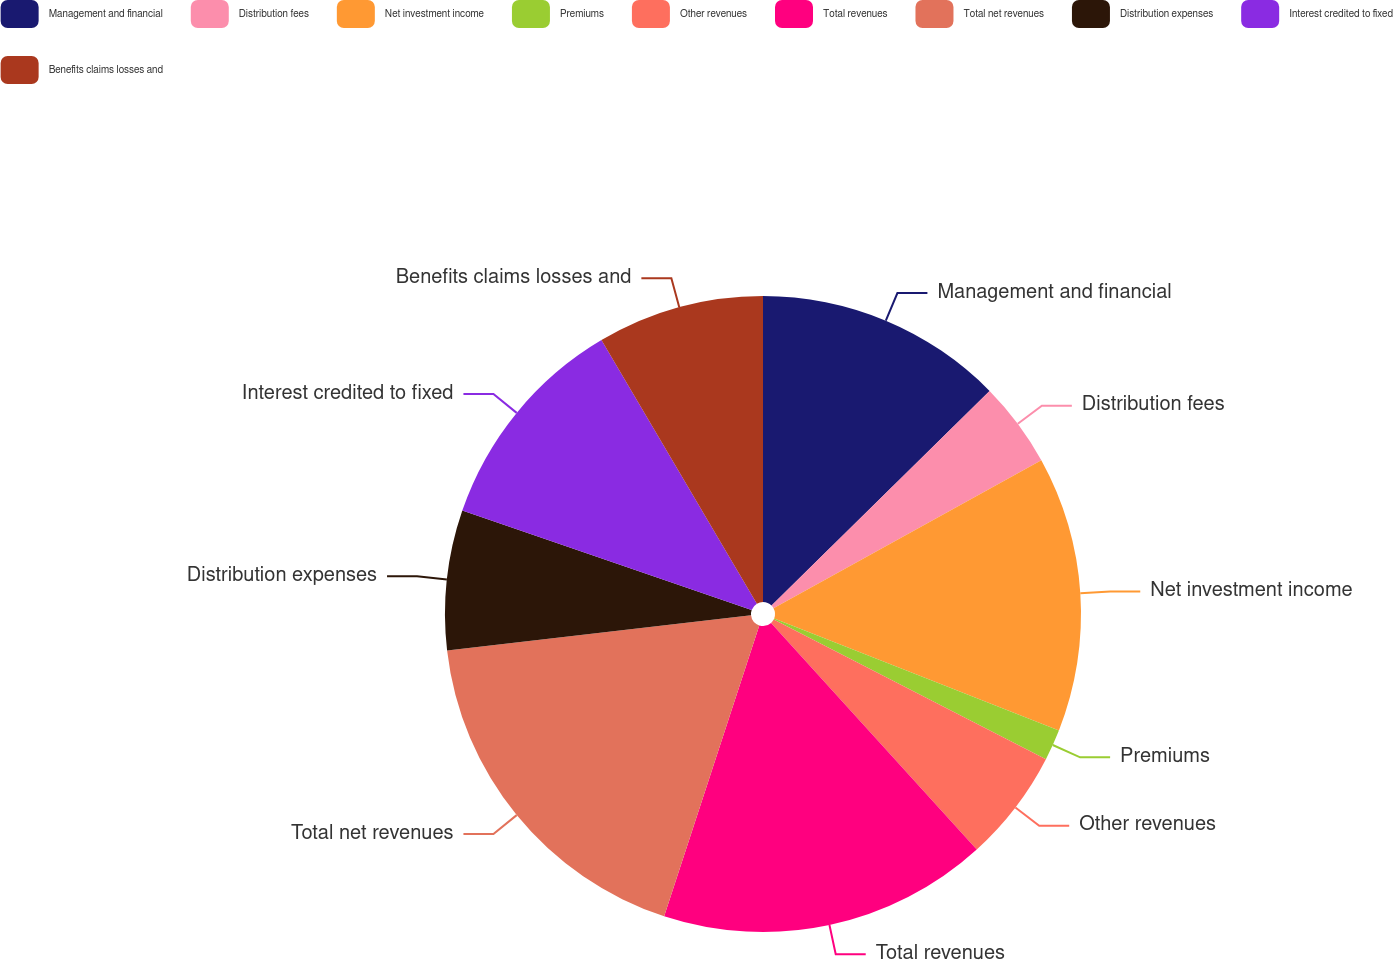Convert chart to OTSL. <chart><loc_0><loc_0><loc_500><loc_500><pie_chart><fcel>Management and financial<fcel>Distribution fees<fcel>Net investment income<fcel>Premiums<fcel>Other revenues<fcel>Total revenues<fcel>Total net revenues<fcel>Distribution expenses<fcel>Interest credited to fixed<fcel>Benefits claims losses and<nl><fcel>12.62%<fcel>4.34%<fcel>14.0%<fcel>1.58%<fcel>5.72%<fcel>16.76%<fcel>18.14%<fcel>7.1%<fcel>11.24%<fcel>8.48%<nl></chart> 